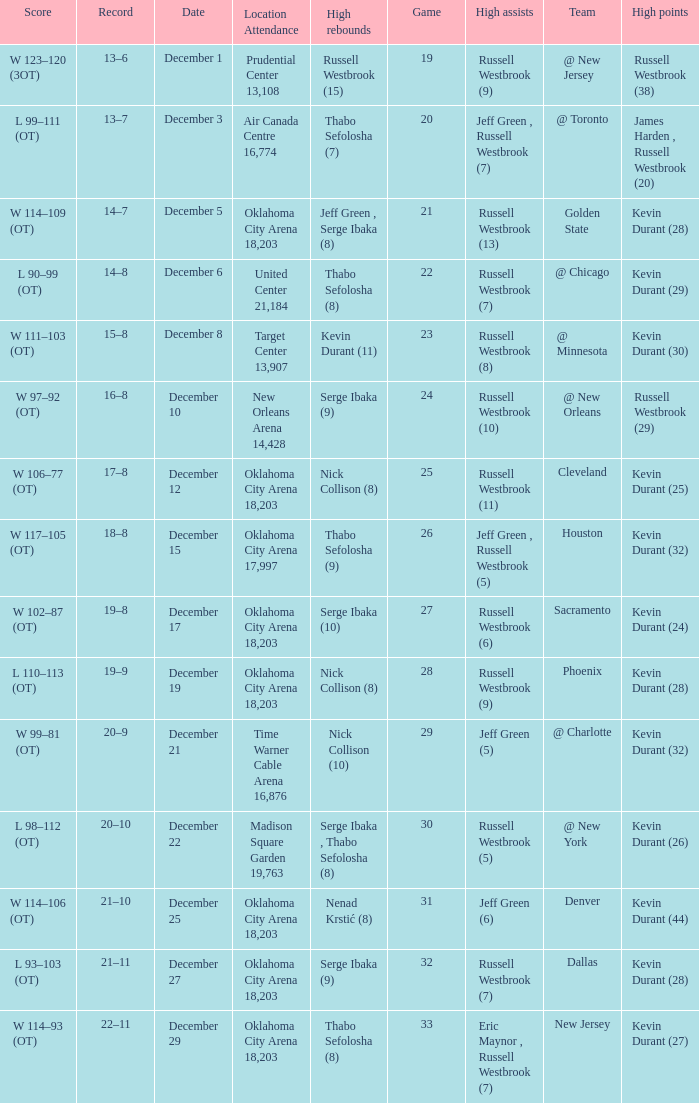What was the record on December 27? 21–11. 